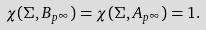Convert formula to latex. <formula><loc_0><loc_0><loc_500><loc_500>\chi ( \Sigma , B _ { p ^ { \infty } } ) = \chi ( \Sigma , A _ { p ^ { \infty } } ) = 1 .</formula> 